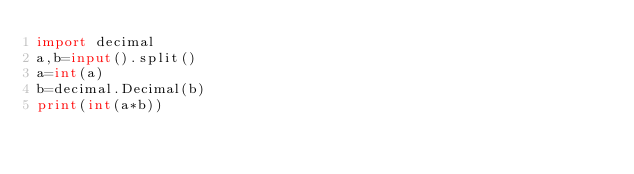<code> <loc_0><loc_0><loc_500><loc_500><_Python_>import decimal
a,b=input().split()
a=int(a)
b=decimal.Decimal(b)
print(int(a*b))</code> 